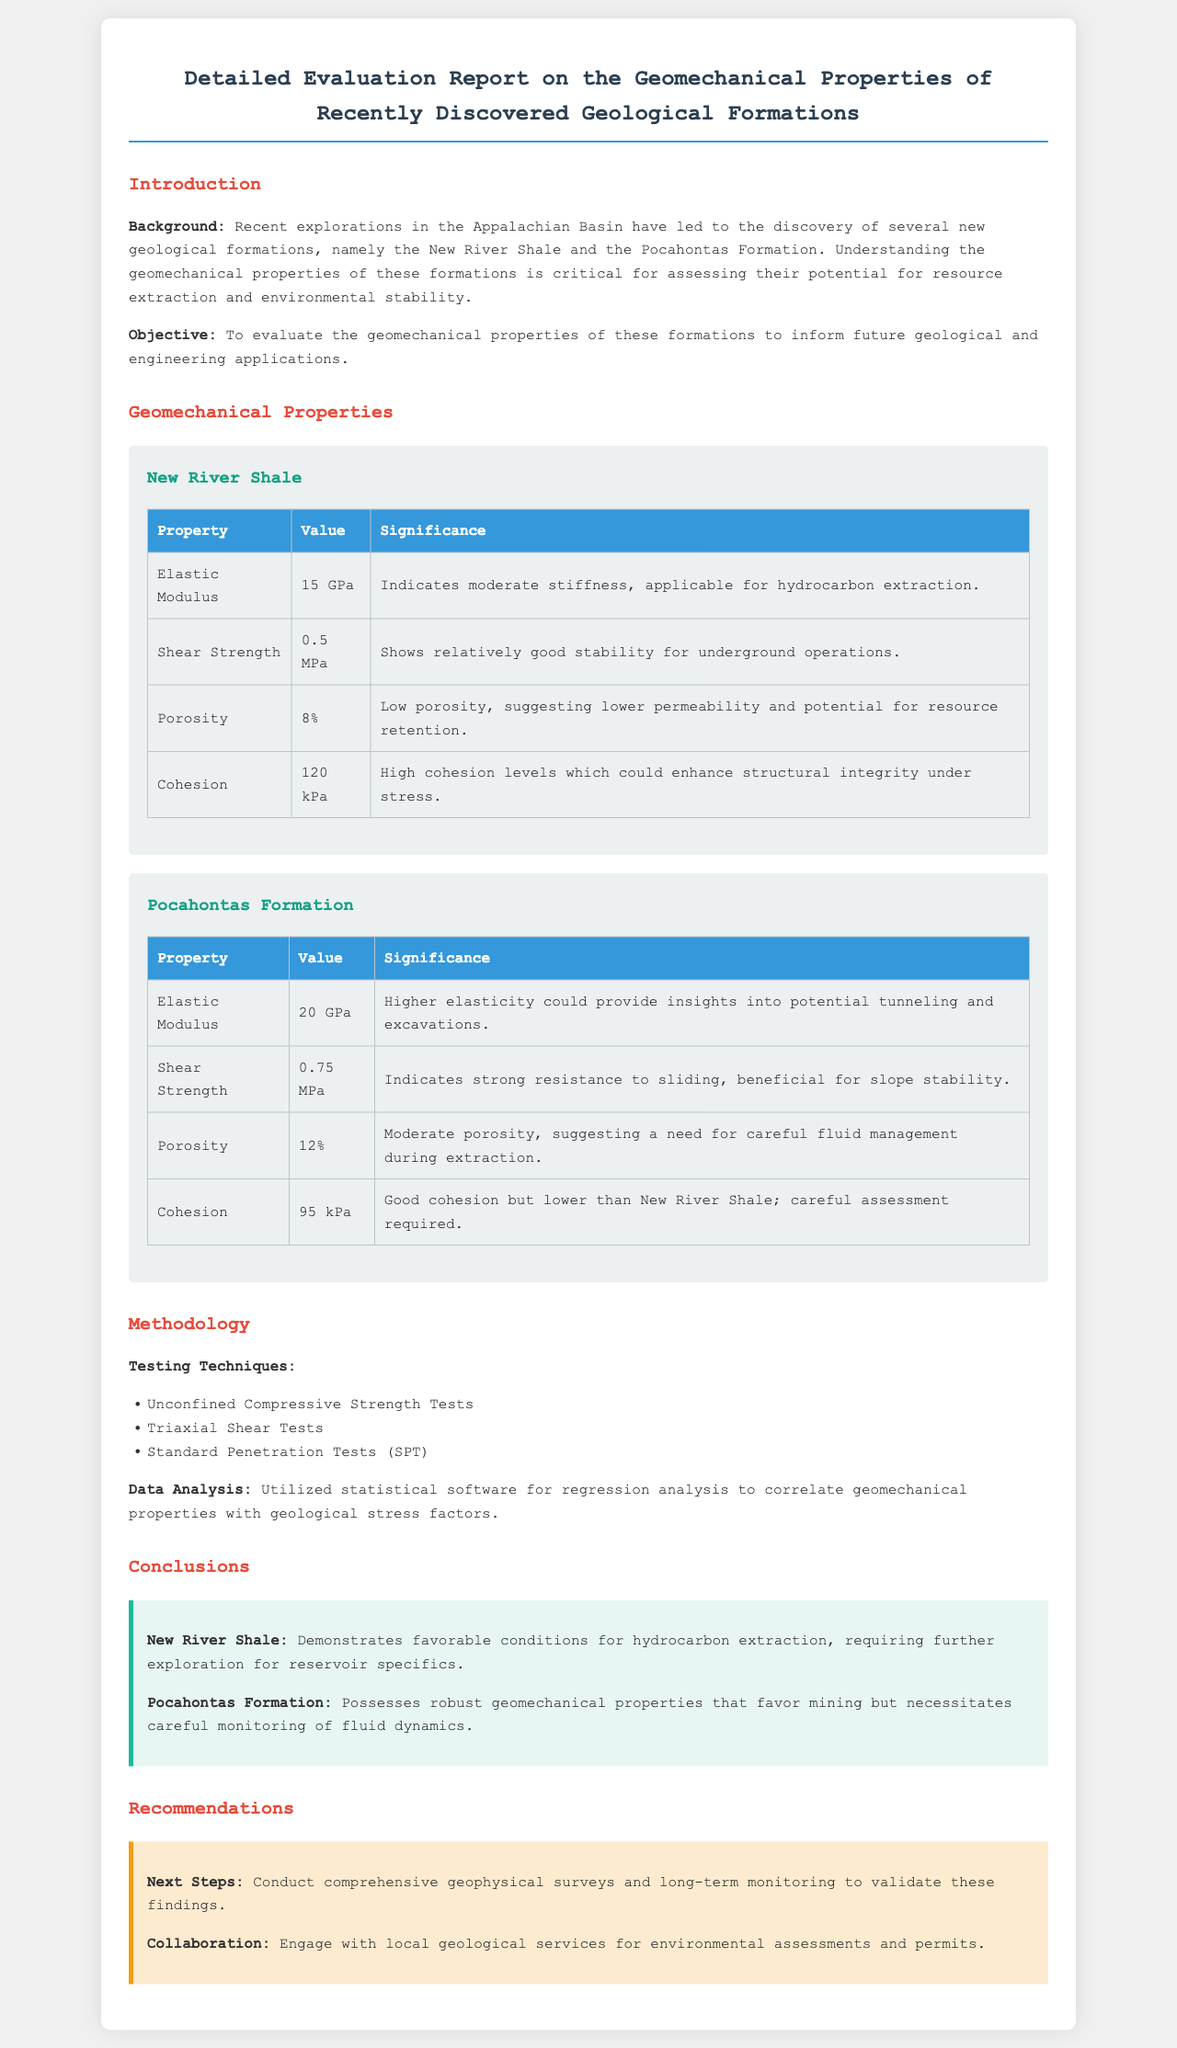What are the names of the geological formations evaluated? The document lists the New River Shale and Pocahontas Formation as the geological formations evaluated.
Answer: New River Shale and Pocahontas Formation What is the elastic modulus of the New River Shale? The elastic modulus for New River Shale is mentioned in the geomechanical properties section of the document.
Answer: 15 GPa What is the shear strength of the Pocahontas Formation? The document specifies the shear strength for the Pocahontas Formation in its properties table.
Answer: 0.75 MPa What testing techniques were used? The methodology section outlines the testing techniques used to evaluate the geomechanical properties.
Answer: Unconfined Compressive Strength Tests, Triaxial Shear Tests, Standard Penetration Tests What is the conclusion regarding the New River Shale? The conclusion section provides insights specific to the New River Shale based on the conducted evaluation.
Answer: Favorable conditions for hydrocarbon extraction What are the recommendations for next steps? The recommendations section outlines the suggested actions following the evaluation of the geological formations.
Answer: Conduct comprehensive geophysical surveys and long-term monitoring Which formation has higher porosity? The comparison of porosity values between the two formations is mentioned in the respective properties tables.
Answer: Pocahontas Formation Why is the shear strength of the Pocahontas Formation significant? The significance of shear strength is provided in the document and is relevant to stability concerns.
Answer: Beneficial for slope stability What is the primary objective of the report? The report states its objective in the introduction section, clarifying its purpose.
Answer: To evaluate the geomechanical properties of these formations 